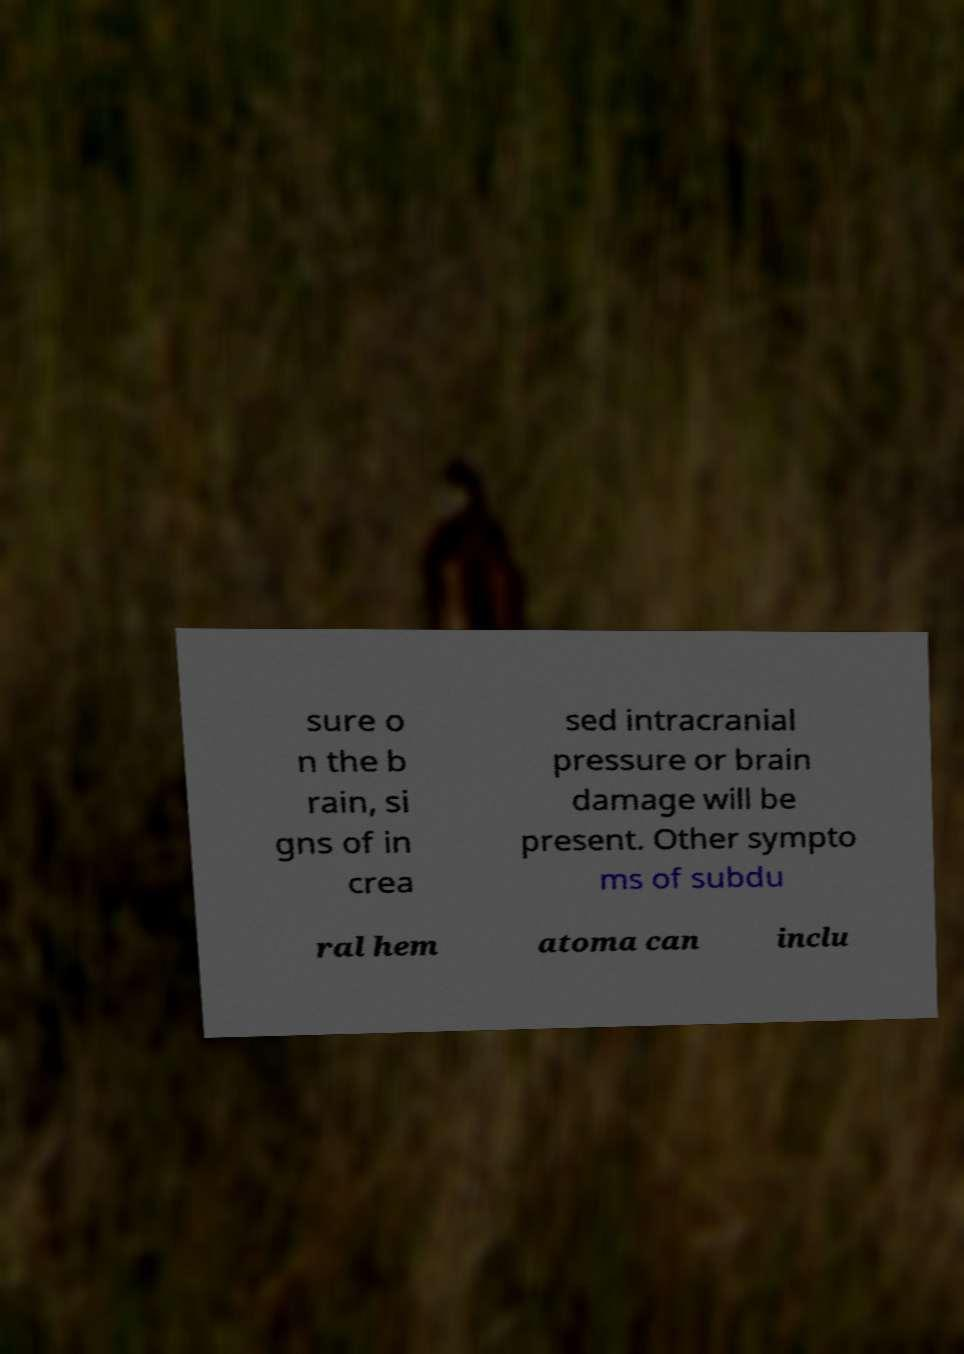For documentation purposes, I need the text within this image transcribed. Could you provide that? sure o n the b rain, si gns of in crea sed intracranial pressure or brain damage will be present. Other sympto ms of subdu ral hem atoma can inclu 